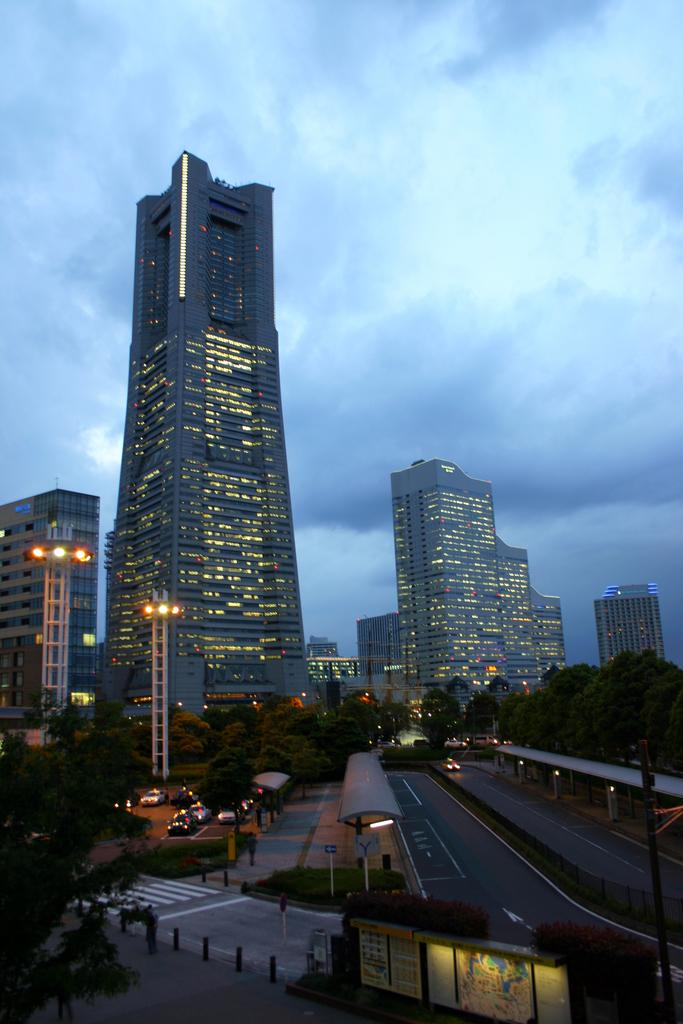What type of structures can be seen in the image? There are buildings in the image. What can be seen illuminating the scene in the image? There are lights in the image. What type of natural elements are present in the image? There are trees in the image. What type of man-made objects are present in the image? There are poles and boards in the image. What type of transportation is visible in the image? There are vehicles on the road in the image. What type of additional structures can be seen in the image? There are sheds in the image. What is visible in the sky at the top of the image? There are clouds in the sky at the top of the image. Can you tell me what the parent is discussing with the child in the image? There is no parent or child present in the image; it features buildings, lights, trees, poles, boards, vehicles, sheds, and clouds. How many bites of the sandwich can be seen in the image? There is no sandwich present in the image. 